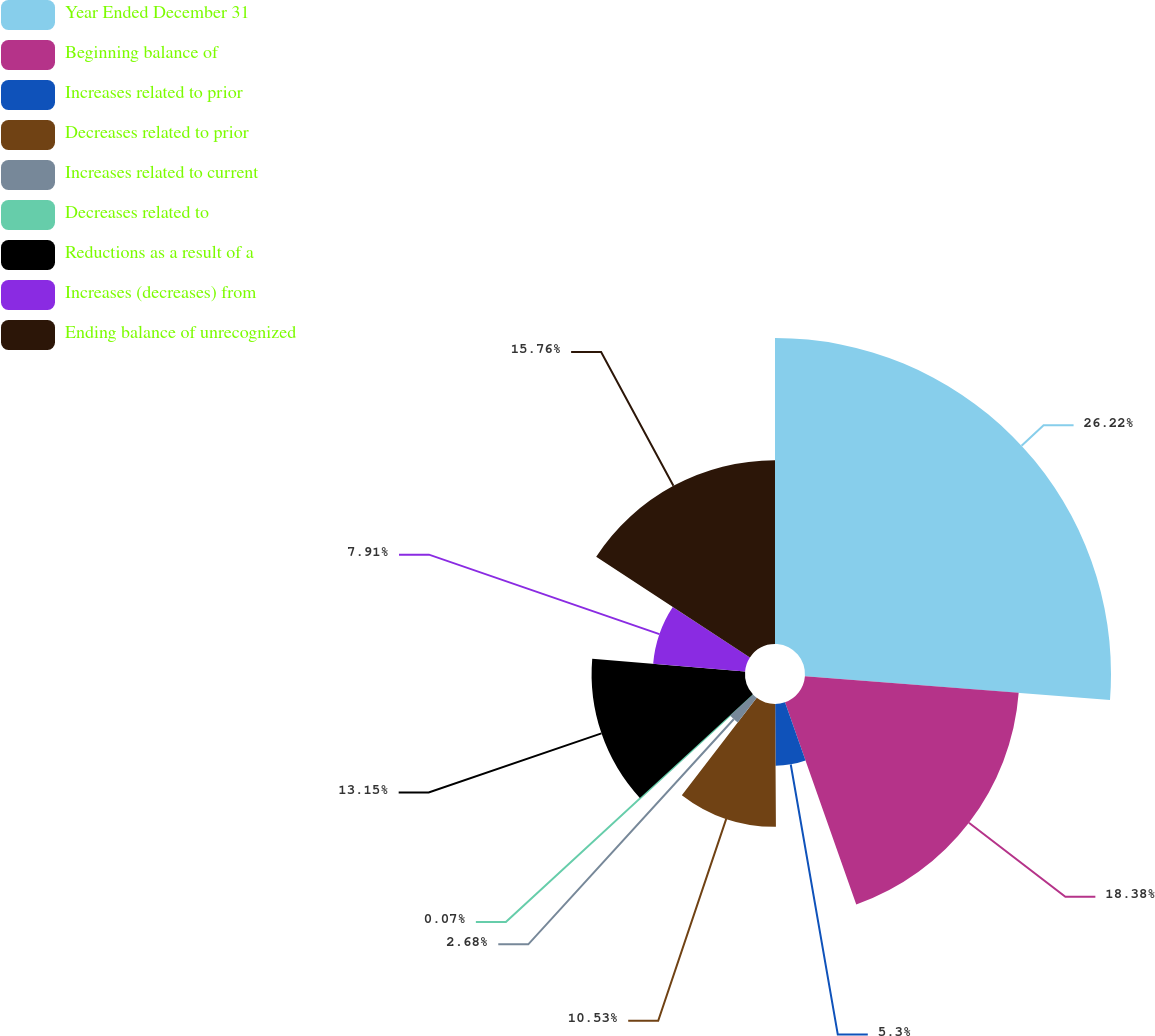Convert chart. <chart><loc_0><loc_0><loc_500><loc_500><pie_chart><fcel>Year Ended December 31<fcel>Beginning balance of<fcel>Increases related to prior<fcel>Decreases related to prior<fcel>Increases related to current<fcel>Decreases related to<fcel>Reductions as a result of a<fcel>Increases (decreases) from<fcel>Ending balance of unrecognized<nl><fcel>26.23%<fcel>18.38%<fcel>5.3%<fcel>10.53%<fcel>2.68%<fcel>0.07%<fcel>13.15%<fcel>7.91%<fcel>15.76%<nl></chart> 